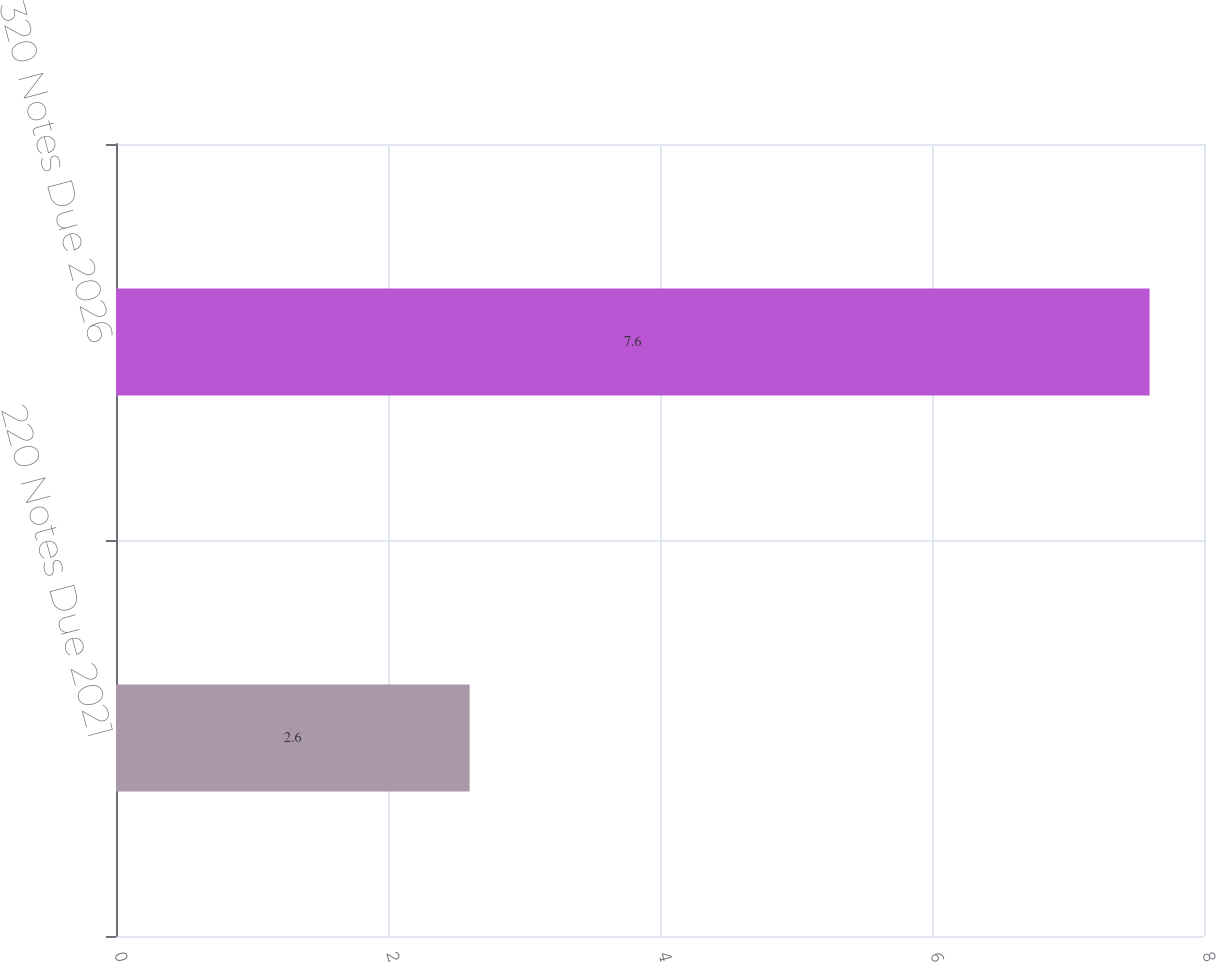Convert chart. <chart><loc_0><loc_0><loc_500><loc_500><bar_chart><fcel>220 Notes Due 2021<fcel>320 Notes Due 2026<nl><fcel>2.6<fcel>7.6<nl></chart> 